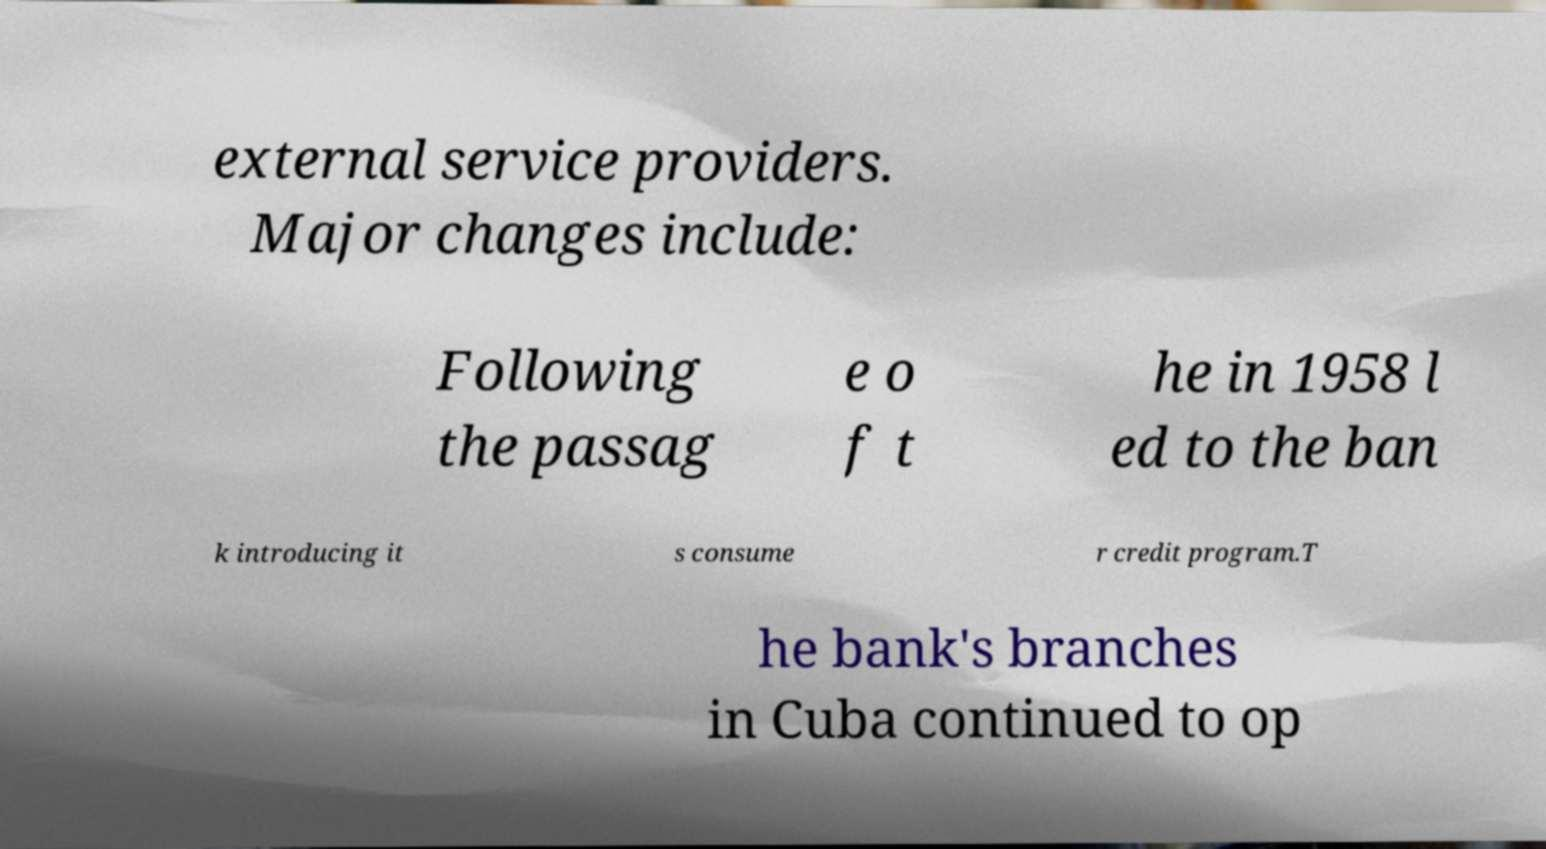Can you accurately transcribe the text from the provided image for me? external service providers. Major changes include: Following the passag e o f t he in 1958 l ed to the ban k introducing it s consume r credit program.T he bank's branches in Cuba continued to op 